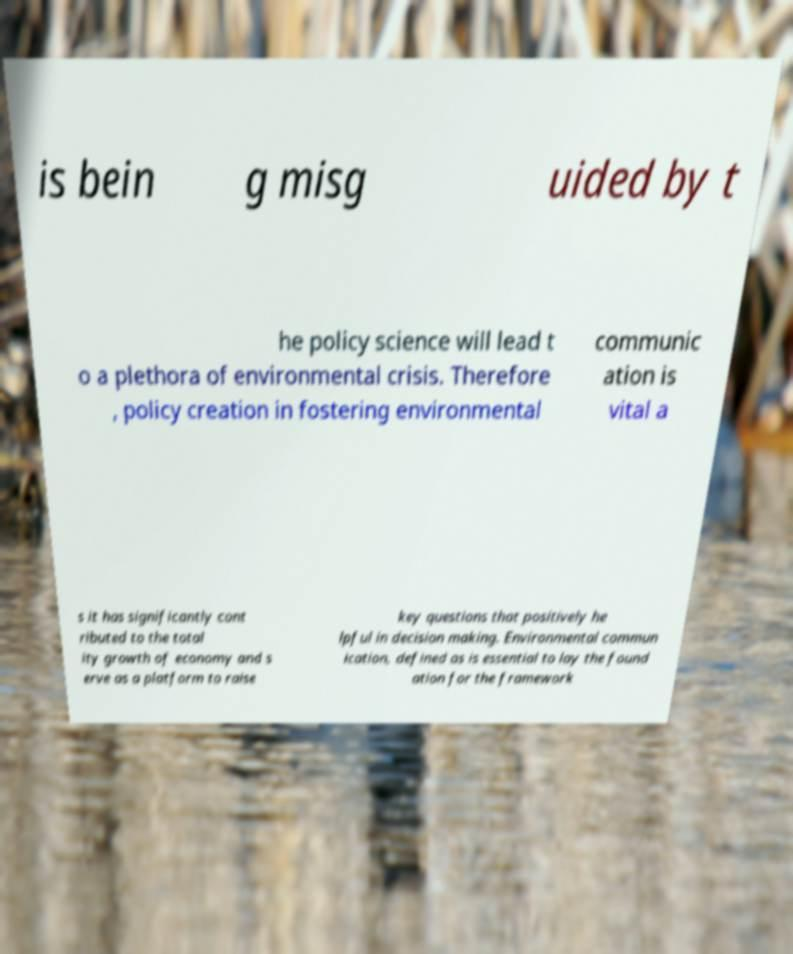Can you read and provide the text displayed in the image?This photo seems to have some interesting text. Can you extract and type it out for me? is bein g misg uided by t he policy science will lead t o a plethora of environmental crisis. Therefore , policy creation in fostering environmental communic ation is vital a s it has significantly cont ributed to the total ity growth of economy and s erve as a platform to raise key questions that positively he lpful in decision making. Environmental commun ication, defined as is essential to lay the found ation for the framework 